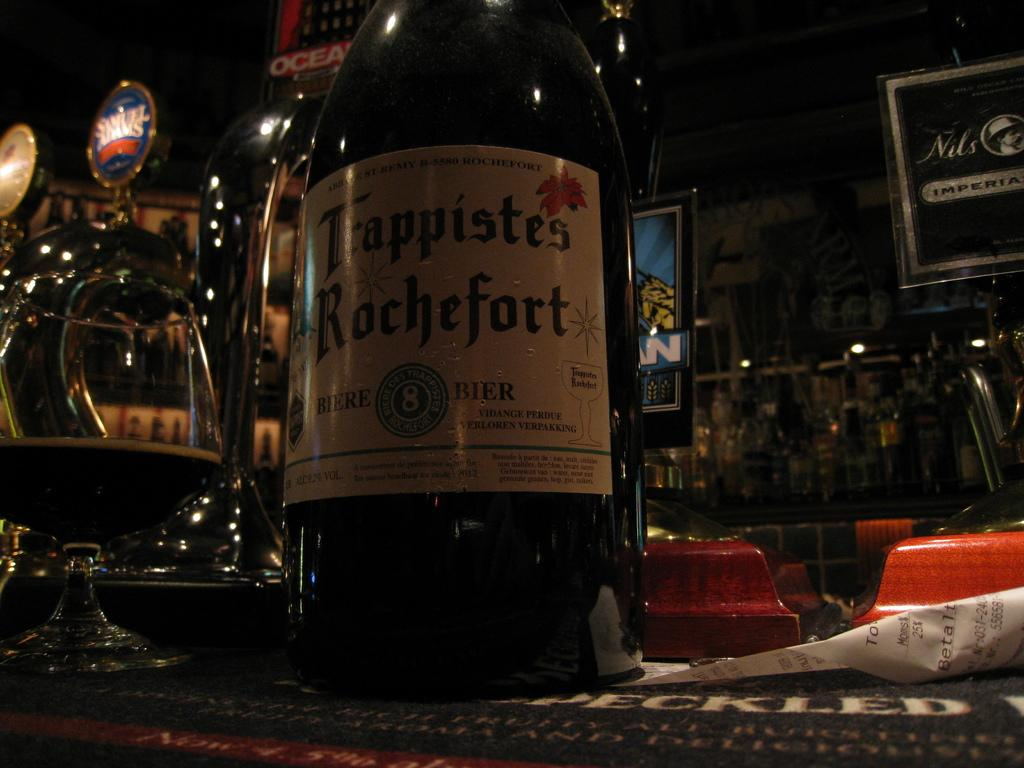<image>
Relay a brief, clear account of the picture shown. Samuel Adams is on tap to the left of the bottle of Rochefort. 